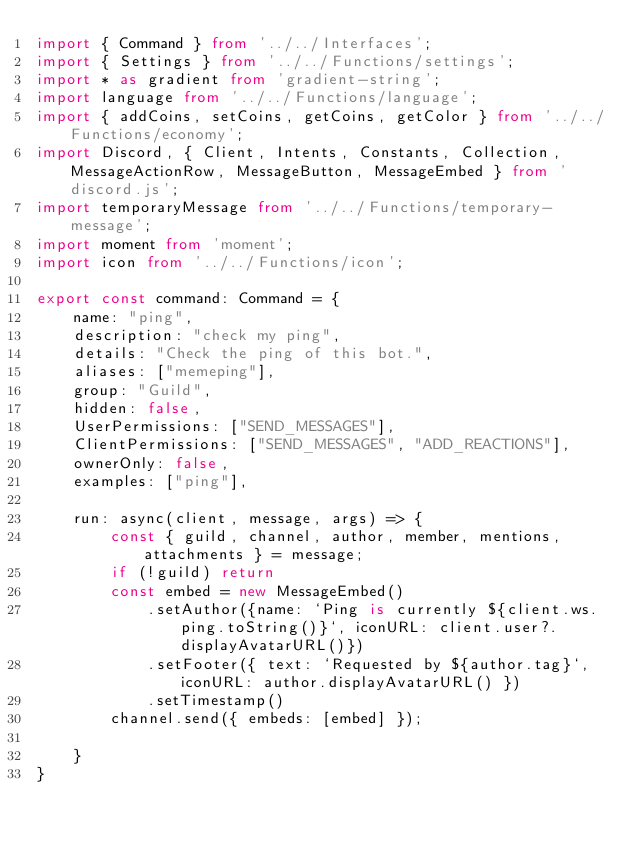Convert code to text. <code><loc_0><loc_0><loc_500><loc_500><_TypeScript_>import { Command } from '../../Interfaces';
import { Settings } from '../../Functions/settings';
import * as gradient from 'gradient-string';
import language from '../../Functions/language';
import { addCoins, setCoins, getCoins, getColor } from '../../Functions/economy';
import Discord, { Client, Intents, Constants, Collection, MessageActionRow, MessageButton, MessageEmbed } from 'discord.js';
import temporaryMessage from '../../Functions/temporary-message';
import moment from 'moment';
import icon from '../../Functions/icon';

export const command: Command = {
    name: "ping",
    description: "check my ping",
    details: "Check the ping of this bot.",
    aliases: ["memeping"],
    group: "Guild",
    hidden: false,
    UserPermissions: ["SEND_MESSAGES"],
    ClientPermissions: ["SEND_MESSAGES", "ADD_REACTIONS"],
    ownerOnly: false,
    examples: ["ping"],
    
    run: async(client, message, args) => {
        const { guild, channel, author, member, mentions, attachments } = message;
        if (!guild) return
        const embed = new MessageEmbed()
            .setAuthor({name: `Ping is currently ${client.ws.ping.toString()}`, iconURL: client.user?.displayAvatarURL()})
            .setFooter({ text: `Requested by ${author.tag}`, iconURL: author.displayAvatarURL() })
            .setTimestamp()
        channel.send({ embeds: [embed] });
        
    }
}</code> 